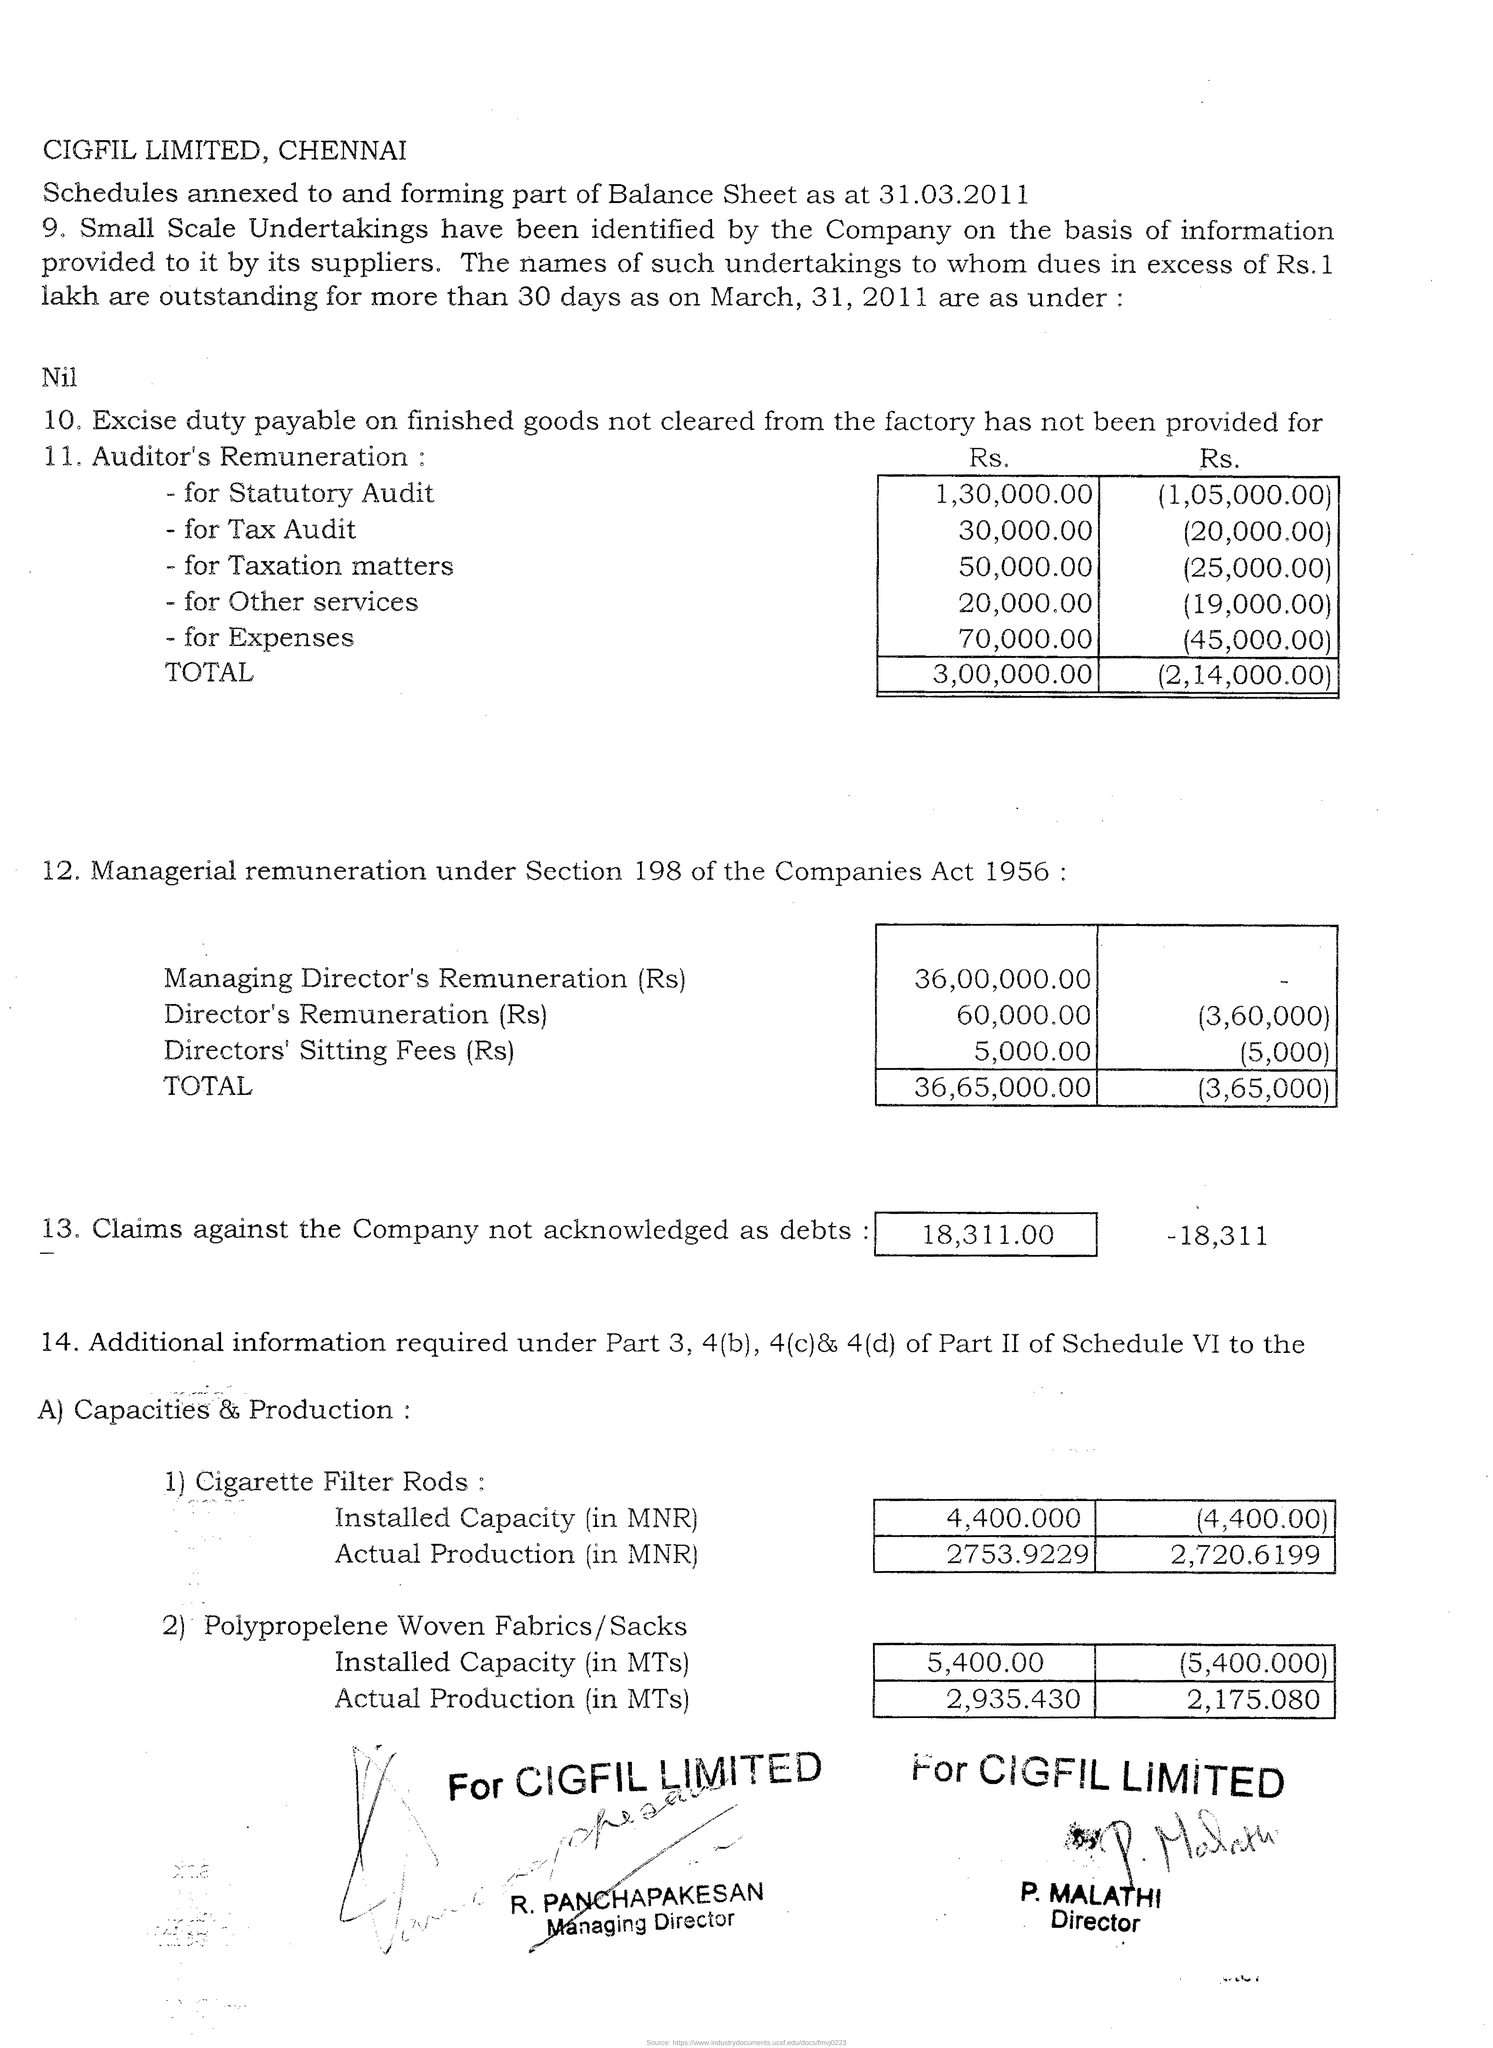List a handful of essential elements in this visual. The company name is CIGFIL LIMITED and it is located in Chennai, as specified at the beginning of this document. The highest amount in the first column of table 1 "Auditor's Remuneration" is 1,30,000.00. The minimum amount in the first column of the second table "12. Managerial remuneration" is 5,000.00. The total amount that has not been allocated for the auditor's remuneration, as per the first column of table 1, is 3,00,000.00. The Managing Director's remuneration, based on the information in the first column of Table 2, is approximately 36,000,000.00 Indian Rupees. 